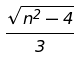<formula> <loc_0><loc_0><loc_500><loc_500>\frac { \sqrt { n ^ { 2 } - 4 } } { 3 }</formula> 